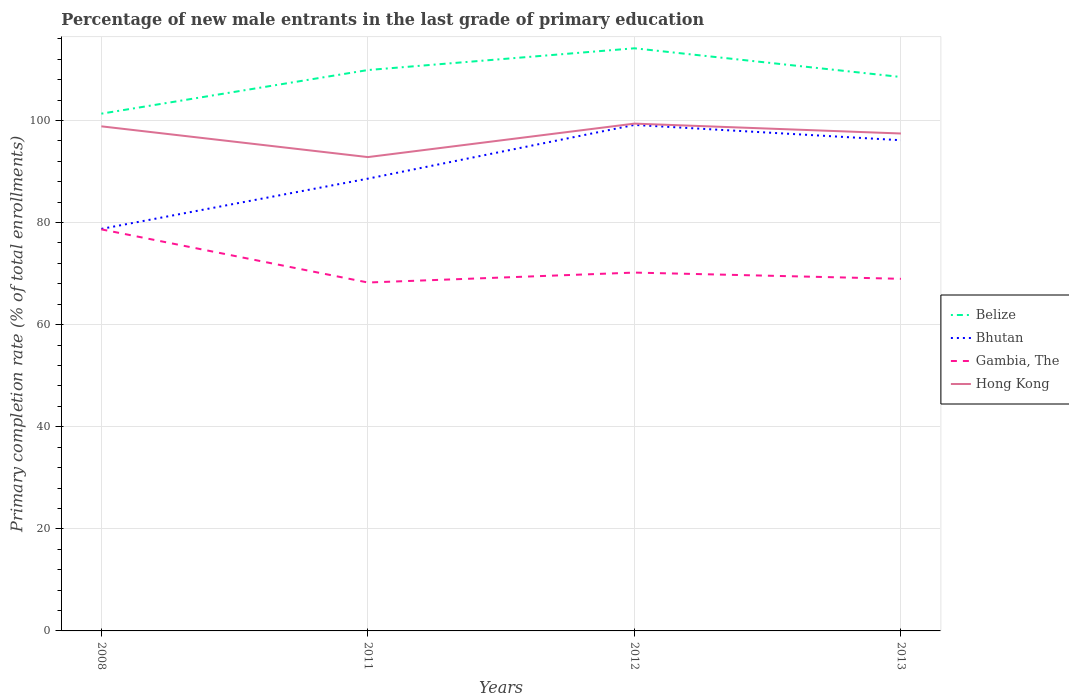How many different coloured lines are there?
Provide a short and direct response. 4. Does the line corresponding to Hong Kong intersect with the line corresponding to Belize?
Your answer should be compact. No. Across all years, what is the maximum percentage of new male entrants in Hong Kong?
Offer a terse response. 92.83. What is the total percentage of new male entrants in Bhutan in the graph?
Offer a terse response. 3. What is the difference between the highest and the second highest percentage of new male entrants in Gambia, The?
Give a very brief answer. 10.41. How many years are there in the graph?
Offer a very short reply. 4. Are the values on the major ticks of Y-axis written in scientific E-notation?
Keep it short and to the point. No. Does the graph contain any zero values?
Your response must be concise. No. Where does the legend appear in the graph?
Your response must be concise. Center right. How many legend labels are there?
Your answer should be compact. 4. How are the legend labels stacked?
Make the answer very short. Vertical. What is the title of the graph?
Your response must be concise. Percentage of new male entrants in the last grade of primary education. Does "Finland" appear as one of the legend labels in the graph?
Offer a terse response. No. What is the label or title of the X-axis?
Your answer should be compact. Years. What is the label or title of the Y-axis?
Make the answer very short. Primary completion rate (% of total enrollments). What is the Primary completion rate (% of total enrollments) of Belize in 2008?
Ensure brevity in your answer.  101.34. What is the Primary completion rate (% of total enrollments) in Bhutan in 2008?
Offer a very short reply. 78.76. What is the Primary completion rate (% of total enrollments) in Gambia, The in 2008?
Offer a terse response. 78.67. What is the Primary completion rate (% of total enrollments) in Hong Kong in 2008?
Make the answer very short. 98.86. What is the Primary completion rate (% of total enrollments) in Belize in 2011?
Your answer should be compact. 109.88. What is the Primary completion rate (% of total enrollments) in Bhutan in 2011?
Offer a terse response. 88.61. What is the Primary completion rate (% of total enrollments) in Gambia, The in 2011?
Ensure brevity in your answer.  68.26. What is the Primary completion rate (% of total enrollments) in Hong Kong in 2011?
Ensure brevity in your answer.  92.83. What is the Primary completion rate (% of total enrollments) of Belize in 2012?
Offer a terse response. 114.15. What is the Primary completion rate (% of total enrollments) of Bhutan in 2012?
Offer a very short reply. 99.14. What is the Primary completion rate (% of total enrollments) in Gambia, The in 2012?
Your answer should be very brief. 70.2. What is the Primary completion rate (% of total enrollments) in Hong Kong in 2012?
Your answer should be compact. 99.39. What is the Primary completion rate (% of total enrollments) of Belize in 2013?
Keep it short and to the point. 108.52. What is the Primary completion rate (% of total enrollments) of Bhutan in 2013?
Offer a terse response. 96.13. What is the Primary completion rate (% of total enrollments) in Gambia, The in 2013?
Offer a terse response. 68.98. What is the Primary completion rate (% of total enrollments) in Hong Kong in 2013?
Keep it short and to the point. 97.45. Across all years, what is the maximum Primary completion rate (% of total enrollments) in Belize?
Provide a succinct answer. 114.15. Across all years, what is the maximum Primary completion rate (% of total enrollments) in Bhutan?
Offer a very short reply. 99.14. Across all years, what is the maximum Primary completion rate (% of total enrollments) of Gambia, The?
Provide a succinct answer. 78.67. Across all years, what is the maximum Primary completion rate (% of total enrollments) of Hong Kong?
Offer a terse response. 99.39. Across all years, what is the minimum Primary completion rate (% of total enrollments) of Belize?
Keep it short and to the point. 101.34. Across all years, what is the minimum Primary completion rate (% of total enrollments) in Bhutan?
Make the answer very short. 78.76. Across all years, what is the minimum Primary completion rate (% of total enrollments) of Gambia, The?
Provide a succinct answer. 68.26. Across all years, what is the minimum Primary completion rate (% of total enrollments) in Hong Kong?
Give a very brief answer. 92.83. What is the total Primary completion rate (% of total enrollments) in Belize in the graph?
Your response must be concise. 433.89. What is the total Primary completion rate (% of total enrollments) of Bhutan in the graph?
Give a very brief answer. 362.64. What is the total Primary completion rate (% of total enrollments) in Gambia, The in the graph?
Keep it short and to the point. 286.11. What is the total Primary completion rate (% of total enrollments) of Hong Kong in the graph?
Your answer should be compact. 388.53. What is the difference between the Primary completion rate (% of total enrollments) in Belize in 2008 and that in 2011?
Give a very brief answer. -8.55. What is the difference between the Primary completion rate (% of total enrollments) in Bhutan in 2008 and that in 2011?
Give a very brief answer. -9.84. What is the difference between the Primary completion rate (% of total enrollments) of Gambia, The in 2008 and that in 2011?
Ensure brevity in your answer.  10.41. What is the difference between the Primary completion rate (% of total enrollments) in Hong Kong in 2008 and that in 2011?
Make the answer very short. 6.02. What is the difference between the Primary completion rate (% of total enrollments) in Belize in 2008 and that in 2012?
Your answer should be compact. -12.81. What is the difference between the Primary completion rate (% of total enrollments) in Bhutan in 2008 and that in 2012?
Provide a succinct answer. -20.37. What is the difference between the Primary completion rate (% of total enrollments) of Gambia, The in 2008 and that in 2012?
Your answer should be very brief. 8.47. What is the difference between the Primary completion rate (% of total enrollments) in Hong Kong in 2008 and that in 2012?
Offer a terse response. -0.53. What is the difference between the Primary completion rate (% of total enrollments) of Belize in 2008 and that in 2013?
Your answer should be very brief. -7.18. What is the difference between the Primary completion rate (% of total enrollments) in Bhutan in 2008 and that in 2013?
Ensure brevity in your answer.  -17.37. What is the difference between the Primary completion rate (% of total enrollments) of Gambia, The in 2008 and that in 2013?
Provide a succinct answer. 9.69. What is the difference between the Primary completion rate (% of total enrollments) of Hong Kong in 2008 and that in 2013?
Your response must be concise. 1.4. What is the difference between the Primary completion rate (% of total enrollments) of Belize in 2011 and that in 2012?
Keep it short and to the point. -4.26. What is the difference between the Primary completion rate (% of total enrollments) in Bhutan in 2011 and that in 2012?
Provide a short and direct response. -10.53. What is the difference between the Primary completion rate (% of total enrollments) of Gambia, The in 2011 and that in 2012?
Your answer should be very brief. -1.95. What is the difference between the Primary completion rate (% of total enrollments) of Hong Kong in 2011 and that in 2012?
Give a very brief answer. -6.56. What is the difference between the Primary completion rate (% of total enrollments) of Belize in 2011 and that in 2013?
Provide a short and direct response. 1.36. What is the difference between the Primary completion rate (% of total enrollments) in Bhutan in 2011 and that in 2013?
Your answer should be compact. -7.53. What is the difference between the Primary completion rate (% of total enrollments) in Gambia, The in 2011 and that in 2013?
Your response must be concise. -0.72. What is the difference between the Primary completion rate (% of total enrollments) of Hong Kong in 2011 and that in 2013?
Provide a succinct answer. -4.62. What is the difference between the Primary completion rate (% of total enrollments) of Belize in 2012 and that in 2013?
Provide a short and direct response. 5.62. What is the difference between the Primary completion rate (% of total enrollments) in Bhutan in 2012 and that in 2013?
Keep it short and to the point. 3. What is the difference between the Primary completion rate (% of total enrollments) of Gambia, The in 2012 and that in 2013?
Offer a very short reply. 1.22. What is the difference between the Primary completion rate (% of total enrollments) of Hong Kong in 2012 and that in 2013?
Offer a terse response. 1.94. What is the difference between the Primary completion rate (% of total enrollments) of Belize in 2008 and the Primary completion rate (% of total enrollments) of Bhutan in 2011?
Make the answer very short. 12.73. What is the difference between the Primary completion rate (% of total enrollments) in Belize in 2008 and the Primary completion rate (% of total enrollments) in Gambia, The in 2011?
Your response must be concise. 33.08. What is the difference between the Primary completion rate (% of total enrollments) in Belize in 2008 and the Primary completion rate (% of total enrollments) in Hong Kong in 2011?
Provide a short and direct response. 8.51. What is the difference between the Primary completion rate (% of total enrollments) of Bhutan in 2008 and the Primary completion rate (% of total enrollments) of Gambia, The in 2011?
Your answer should be very brief. 10.51. What is the difference between the Primary completion rate (% of total enrollments) of Bhutan in 2008 and the Primary completion rate (% of total enrollments) of Hong Kong in 2011?
Ensure brevity in your answer.  -14.07. What is the difference between the Primary completion rate (% of total enrollments) of Gambia, The in 2008 and the Primary completion rate (% of total enrollments) of Hong Kong in 2011?
Offer a very short reply. -14.16. What is the difference between the Primary completion rate (% of total enrollments) of Belize in 2008 and the Primary completion rate (% of total enrollments) of Bhutan in 2012?
Provide a succinct answer. 2.2. What is the difference between the Primary completion rate (% of total enrollments) of Belize in 2008 and the Primary completion rate (% of total enrollments) of Gambia, The in 2012?
Make the answer very short. 31.13. What is the difference between the Primary completion rate (% of total enrollments) in Belize in 2008 and the Primary completion rate (% of total enrollments) in Hong Kong in 2012?
Offer a terse response. 1.95. What is the difference between the Primary completion rate (% of total enrollments) of Bhutan in 2008 and the Primary completion rate (% of total enrollments) of Gambia, The in 2012?
Your response must be concise. 8.56. What is the difference between the Primary completion rate (% of total enrollments) in Bhutan in 2008 and the Primary completion rate (% of total enrollments) in Hong Kong in 2012?
Ensure brevity in your answer.  -20.62. What is the difference between the Primary completion rate (% of total enrollments) of Gambia, The in 2008 and the Primary completion rate (% of total enrollments) of Hong Kong in 2012?
Offer a very short reply. -20.72. What is the difference between the Primary completion rate (% of total enrollments) in Belize in 2008 and the Primary completion rate (% of total enrollments) in Bhutan in 2013?
Your answer should be very brief. 5.2. What is the difference between the Primary completion rate (% of total enrollments) in Belize in 2008 and the Primary completion rate (% of total enrollments) in Gambia, The in 2013?
Your answer should be very brief. 32.36. What is the difference between the Primary completion rate (% of total enrollments) in Belize in 2008 and the Primary completion rate (% of total enrollments) in Hong Kong in 2013?
Provide a succinct answer. 3.88. What is the difference between the Primary completion rate (% of total enrollments) in Bhutan in 2008 and the Primary completion rate (% of total enrollments) in Gambia, The in 2013?
Your answer should be compact. 9.78. What is the difference between the Primary completion rate (% of total enrollments) of Bhutan in 2008 and the Primary completion rate (% of total enrollments) of Hong Kong in 2013?
Your answer should be compact. -18.69. What is the difference between the Primary completion rate (% of total enrollments) in Gambia, The in 2008 and the Primary completion rate (% of total enrollments) in Hong Kong in 2013?
Your answer should be very brief. -18.78. What is the difference between the Primary completion rate (% of total enrollments) in Belize in 2011 and the Primary completion rate (% of total enrollments) in Bhutan in 2012?
Provide a succinct answer. 10.75. What is the difference between the Primary completion rate (% of total enrollments) in Belize in 2011 and the Primary completion rate (% of total enrollments) in Gambia, The in 2012?
Keep it short and to the point. 39.68. What is the difference between the Primary completion rate (% of total enrollments) of Belize in 2011 and the Primary completion rate (% of total enrollments) of Hong Kong in 2012?
Your response must be concise. 10.5. What is the difference between the Primary completion rate (% of total enrollments) of Bhutan in 2011 and the Primary completion rate (% of total enrollments) of Gambia, The in 2012?
Ensure brevity in your answer.  18.4. What is the difference between the Primary completion rate (% of total enrollments) in Bhutan in 2011 and the Primary completion rate (% of total enrollments) in Hong Kong in 2012?
Offer a very short reply. -10.78. What is the difference between the Primary completion rate (% of total enrollments) of Gambia, The in 2011 and the Primary completion rate (% of total enrollments) of Hong Kong in 2012?
Give a very brief answer. -31.13. What is the difference between the Primary completion rate (% of total enrollments) in Belize in 2011 and the Primary completion rate (% of total enrollments) in Bhutan in 2013?
Keep it short and to the point. 13.75. What is the difference between the Primary completion rate (% of total enrollments) of Belize in 2011 and the Primary completion rate (% of total enrollments) of Gambia, The in 2013?
Your answer should be very brief. 40.9. What is the difference between the Primary completion rate (% of total enrollments) of Belize in 2011 and the Primary completion rate (% of total enrollments) of Hong Kong in 2013?
Provide a short and direct response. 12.43. What is the difference between the Primary completion rate (% of total enrollments) in Bhutan in 2011 and the Primary completion rate (% of total enrollments) in Gambia, The in 2013?
Ensure brevity in your answer.  19.62. What is the difference between the Primary completion rate (% of total enrollments) of Bhutan in 2011 and the Primary completion rate (% of total enrollments) of Hong Kong in 2013?
Your answer should be very brief. -8.85. What is the difference between the Primary completion rate (% of total enrollments) of Gambia, The in 2011 and the Primary completion rate (% of total enrollments) of Hong Kong in 2013?
Your answer should be compact. -29.19. What is the difference between the Primary completion rate (% of total enrollments) in Belize in 2012 and the Primary completion rate (% of total enrollments) in Bhutan in 2013?
Your answer should be compact. 18.01. What is the difference between the Primary completion rate (% of total enrollments) in Belize in 2012 and the Primary completion rate (% of total enrollments) in Gambia, The in 2013?
Provide a short and direct response. 45.17. What is the difference between the Primary completion rate (% of total enrollments) of Belize in 2012 and the Primary completion rate (% of total enrollments) of Hong Kong in 2013?
Make the answer very short. 16.69. What is the difference between the Primary completion rate (% of total enrollments) of Bhutan in 2012 and the Primary completion rate (% of total enrollments) of Gambia, The in 2013?
Ensure brevity in your answer.  30.15. What is the difference between the Primary completion rate (% of total enrollments) of Bhutan in 2012 and the Primary completion rate (% of total enrollments) of Hong Kong in 2013?
Make the answer very short. 1.68. What is the difference between the Primary completion rate (% of total enrollments) in Gambia, The in 2012 and the Primary completion rate (% of total enrollments) in Hong Kong in 2013?
Offer a very short reply. -27.25. What is the average Primary completion rate (% of total enrollments) of Belize per year?
Provide a short and direct response. 108.47. What is the average Primary completion rate (% of total enrollments) in Bhutan per year?
Keep it short and to the point. 90.66. What is the average Primary completion rate (% of total enrollments) in Gambia, The per year?
Give a very brief answer. 71.53. What is the average Primary completion rate (% of total enrollments) in Hong Kong per year?
Offer a terse response. 97.13. In the year 2008, what is the difference between the Primary completion rate (% of total enrollments) of Belize and Primary completion rate (% of total enrollments) of Bhutan?
Give a very brief answer. 22.57. In the year 2008, what is the difference between the Primary completion rate (% of total enrollments) of Belize and Primary completion rate (% of total enrollments) of Gambia, The?
Your response must be concise. 22.67. In the year 2008, what is the difference between the Primary completion rate (% of total enrollments) in Belize and Primary completion rate (% of total enrollments) in Hong Kong?
Your answer should be very brief. 2.48. In the year 2008, what is the difference between the Primary completion rate (% of total enrollments) of Bhutan and Primary completion rate (% of total enrollments) of Gambia, The?
Provide a short and direct response. 0.09. In the year 2008, what is the difference between the Primary completion rate (% of total enrollments) of Bhutan and Primary completion rate (% of total enrollments) of Hong Kong?
Give a very brief answer. -20.09. In the year 2008, what is the difference between the Primary completion rate (% of total enrollments) in Gambia, The and Primary completion rate (% of total enrollments) in Hong Kong?
Provide a short and direct response. -20.18. In the year 2011, what is the difference between the Primary completion rate (% of total enrollments) in Belize and Primary completion rate (% of total enrollments) in Bhutan?
Your answer should be compact. 21.28. In the year 2011, what is the difference between the Primary completion rate (% of total enrollments) of Belize and Primary completion rate (% of total enrollments) of Gambia, The?
Offer a very short reply. 41.63. In the year 2011, what is the difference between the Primary completion rate (% of total enrollments) in Belize and Primary completion rate (% of total enrollments) in Hong Kong?
Provide a succinct answer. 17.05. In the year 2011, what is the difference between the Primary completion rate (% of total enrollments) of Bhutan and Primary completion rate (% of total enrollments) of Gambia, The?
Your answer should be very brief. 20.35. In the year 2011, what is the difference between the Primary completion rate (% of total enrollments) of Bhutan and Primary completion rate (% of total enrollments) of Hong Kong?
Make the answer very short. -4.23. In the year 2011, what is the difference between the Primary completion rate (% of total enrollments) of Gambia, The and Primary completion rate (% of total enrollments) of Hong Kong?
Give a very brief answer. -24.57. In the year 2012, what is the difference between the Primary completion rate (% of total enrollments) of Belize and Primary completion rate (% of total enrollments) of Bhutan?
Your answer should be very brief. 15.01. In the year 2012, what is the difference between the Primary completion rate (% of total enrollments) in Belize and Primary completion rate (% of total enrollments) in Gambia, The?
Keep it short and to the point. 43.94. In the year 2012, what is the difference between the Primary completion rate (% of total enrollments) of Belize and Primary completion rate (% of total enrollments) of Hong Kong?
Offer a terse response. 14.76. In the year 2012, what is the difference between the Primary completion rate (% of total enrollments) in Bhutan and Primary completion rate (% of total enrollments) in Gambia, The?
Your response must be concise. 28.93. In the year 2012, what is the difference between the Primary completion rate (% of total enrollments) in Bhutan and Primary completion rate (% of total enrollments) in Hong Kong?
Offer a terse response. -0.25. In the year 2012, what is the difference between the Primary completion rate (% of total enrollments) in Gambia, The and Primary completion rate (% of total enrollments) in Hong Kong?
Provide a succinct answer. -29.18. In the year 2013, what is the difference between the Primary completion rate (% of total enrollments) in Belize and Primary completion rate (% of total enrollments) in Bhutan?
Offer a very short reply. 12.39. In the year 2013, what is the difference between the Primary completion rate (% of total enrollments) of Belize and Primary completion rate (% of total enrollments) of Gambia, The?
Your answer should be compact. 39.54. In the year 2013, what is the difference between the Primary completion rate (% of total enrollments) of Belize and Primary completion rate (% of total enrollments) of Hong Kong?
Give a very brief answer. 11.07. In the year 2013, what is the difference between the Primary completion rate (% of total enrollments) of Bhutan and Primary completion rate (% of total enrollments) of Gambia, The?
Ensure brevity in your answer.  27.15. In the year 2013, what is the difference between the Primary completion rate (% of total enrollments) of Bhutan and Primary completion rate (% of total enrollments) of Hong Kong?
Give a very brief answer. -1.32. In the year 2013, what is the difference between the Primary completion rate (% of total enrollments) in Gambia, The and Primary completion rate (% of total enrollments) in Hong Kong?
Offer a terse response. -28.47. What is the ratio of the Primary completion rate (% of total enrollments) in Belize in 2008 to that in 2011?
Offer a terse response. 0.92. What is the ratio of the Primary completion rate (% of total enrollments) in Gambia, The in 2008 to that in 2011?
Ensure brevity in your answer.  1.15. What is the ratio of the Primary completion rate (% of total enrollments) of Hong Kong in 2008 to that in 2011?
Your answer should be compact. 1.06. What is the ratio of the Primary completion rate (% of total enrollments) in Belize in 2008 to that in 2012?
Keep it short and to the point. 0.89. What is the ratio of the Primary completion rate (% of total enrollments) in Bhutan in 2008 to that in 2012?
Your answer should be compact. 0.79. What is the ratio of the Primary completion rate (% of total enrollments) of Gambia, The in 2008 to that in 2012?
Your answer should be compact. 1.12. What is the ratio of the Primary completion rate (% of total enrollments) of Belize in 2008 to that in 2013?
Give a very brief answer. 0.93. What is the ratio of the Primary completion rate (% of total enrollments) in Bhutan in 2008 to that in 2013?
Provide a short and direct response. 0.82. What is the ratio of the Primary completion rate (% of total enrollments) in Gambia, The in 2008 to that in 2013?
Offer a terse response. 1.14. What is the ratio of the Primary completion rate (% of total enrollments) of Hong Kong in 2008 to that in 2013?
Give a very brief answer. 1.01. What is the ratio of the Primary completion rate (% of total enrollments) of Belize in 2011 to that in 2012?
Ensure brevity in your answer.  0.96. What is the ratio of the Primary completion rate (% of total enrollments) of Bhutan in 2011 to that in 2012?
Provide a short and direct response. 0.89. What is the ratio of the Primary completion rate (% of total enrollments) in Gambia, The in 2011 to that in 2012?
Offer a terse response. 0.97. What is the ratio of the Primary completion rate (% of total enrollments) in Hong Kong in 2011 to that in 2012?
Your response must be concise. 0.93. What is the ratio of the Primary completion rate (% of total enrollments) of Belize in 2011 to that in 2013?
Offer a very short reply. 1.01. What is the ratio of the Primary completion rate (% of total enrollments) in Bhutan in 2011 to that in 2013?
Your answer should be compact. 0.92. What is the ratio of the Primary completion rate (% of total enrollments) in Gambia, The in 2011 to that in 2013?
Offer a very short reply. 0.99. What is the ratio of the Primary completion rate (% of total enrollments) in Hong Kong in 2011 to that in 2013?
Give a very brief answer. 0.95. What is the ratio of the Primary completion rate (% of total enrollments) in Belize in 2012 to that in 2013?
Your answer should be very brief. 1.05. What is the ratio of the Primary completion rate (% of total enrollments) of Bhutan in 2012 to that in 2013?
Your answer should be very brief. 1.03. What is the ratio of the Primary completion rate (% of total enrollments) of Gambia, The in 2012 to that in 2013?
Give a very brief answer. 1.02. What is the ratio of the Primary completion rate (% of total enrollments) of Hong Kong in 2012 to that in 2013?
Offer a terse response. 1.02. What is the difference between the highest and the second highest Primary completion rate (% of total enrollments) in Belize?
Your response must be concise. 4.26. What is the difference between the highest and the second highest Primary completion rate (% of total enrollments) of Bhutan?
Provide a succinct answer. 3. What is the difference between the highest and the second highest Primary completion rate (% of total enrollments) in Gambia, The?
Your answer should be compact. 8.47. What is the difference between the highest and the second highest Primary completion rate (% of total enrollments) in Hong Kong?
Your response must be concise. 0.53. What is the difference between the highest and the lowest Primary completion rate (% of total enrollments) of Belize?
Offer a terse response. 12.81. What is the difference between the highest and the lowest Primary completion rate (% of total enrollments) in Bhutan?
Offer a terse response. 20.37. What is the difference between the highest and the lowest Primary completion rate (% of total enrollments) in Gambia, The?
Your answer should be compact. 10.41. What is the difference between the highest and the lowest Primary completion rate (% of total enrollments) of Hong Kong?
Your response must be concise. 6.56. 